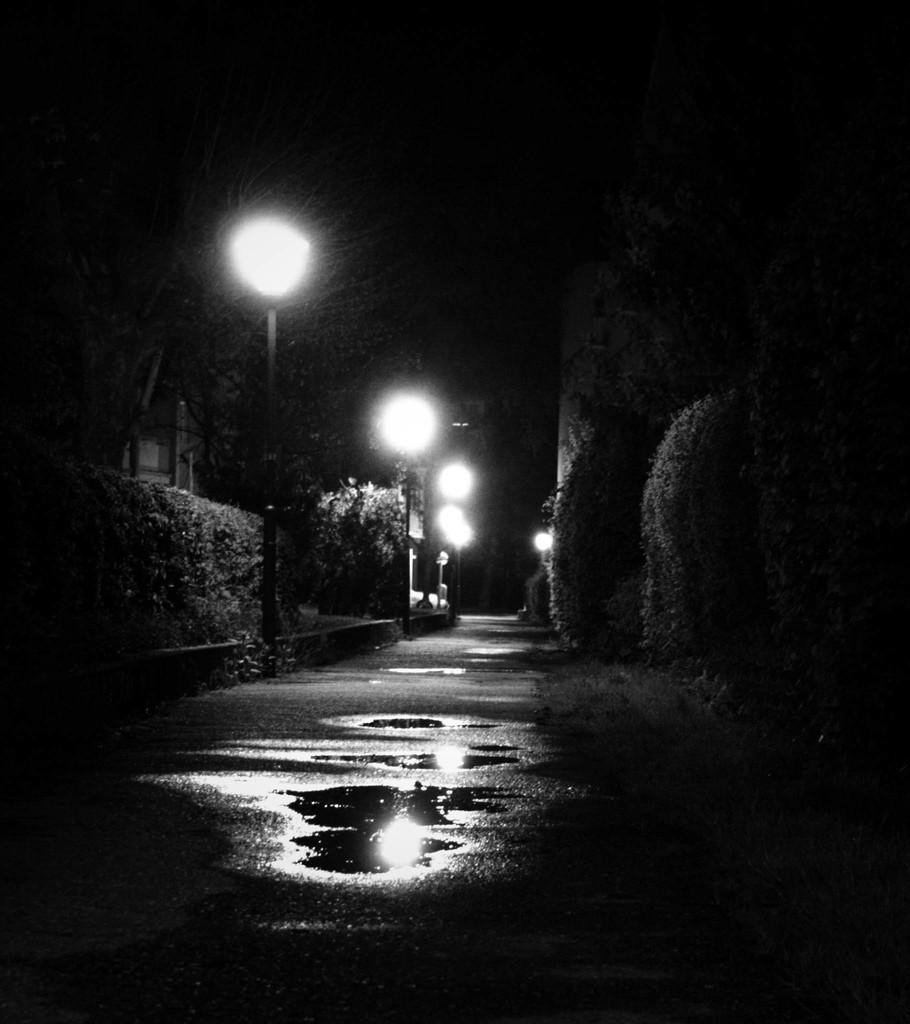What is the primary feature of the landscape in the image? There are many trees in the image. What type of lighting is present along the road? There are street lamps on the road. Is there any indication of water on the road in the image? Yes, there is some water on the road. Where is the nearest hospital in the image? There is no hospital visible in the image. What type of hook can be seen hanging from the trees in the image? There are no hooks present in the image; it features trees, street lamps, and water on the road. 